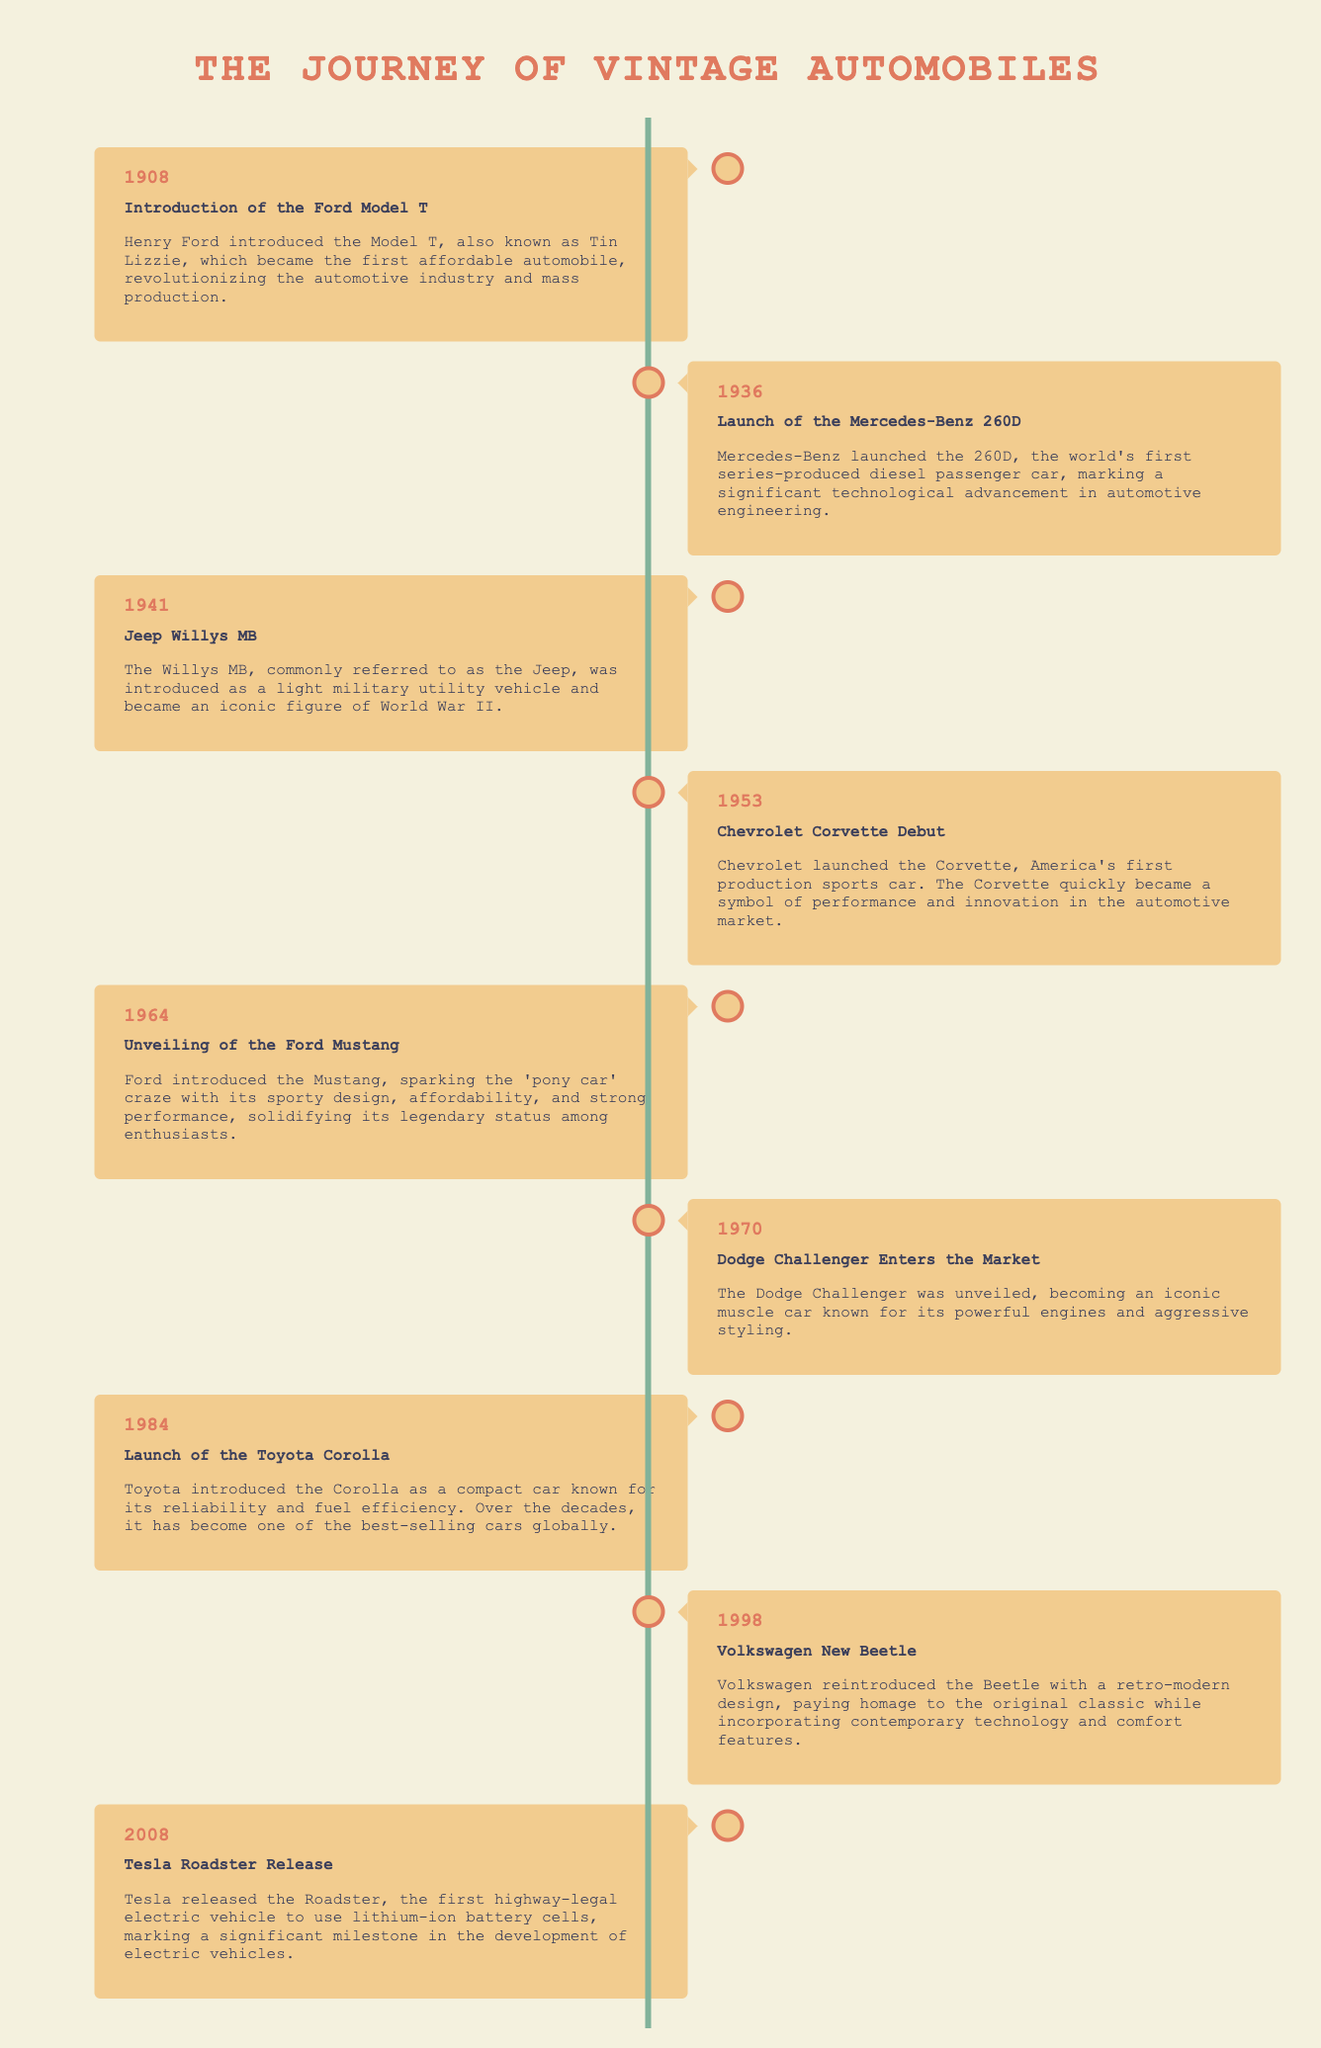what year was the Ford Model T introduced? The document states that the Ford Model T was introduced in 1908.
Answer: 1908 which automobile is known as America's first production sports car? According to the timeline, the Chevrolet Corvette is recognized as America's first production sports car.
Answer: Chevrolet Corvette what significant vehicle was launched by Mercedes-Benz in 1936? The document indicates that the Mercedes-Benz 260D was launched in 1936.
Answer: Mercedes-Benz 260D what model did Ford unveil in 1964 that sparked the 'pony car' craze? The timeline mentions that Ford unveiled the Mustang in 1964, which sparked the 'pony car' craze.
Answer: Mustang how many years are represented between the introduction of the Model T and the launch of the Tesla Roadster? The years in question are 1908 and 2008, meaning there are 100 years between them.
Answer: 100 years what revolutionary feature did Tesla introduce with the release of their Roadster in 2008? The document states that Tesla released the Roadster as the first highway-legal electric vehicle to use lithium-ion battery cells.
Answer: lithium-ion battery cells which iconic military vehicle was introduced in 1941? The timeline notes that the Willys MB, commonly referred to as the Jeep, was introduced in 1941.
Answer: Willys MB what type of vehicle was the Dodge Challenger known for in 1970? The document highlights that the Dodge Challenger became an iconic muscle car in 1970.
Answer: muscle car what color is the background of the timeline? It is mentioned in the style section that the background color is #f4f1de.
Answer: #f4f1de 